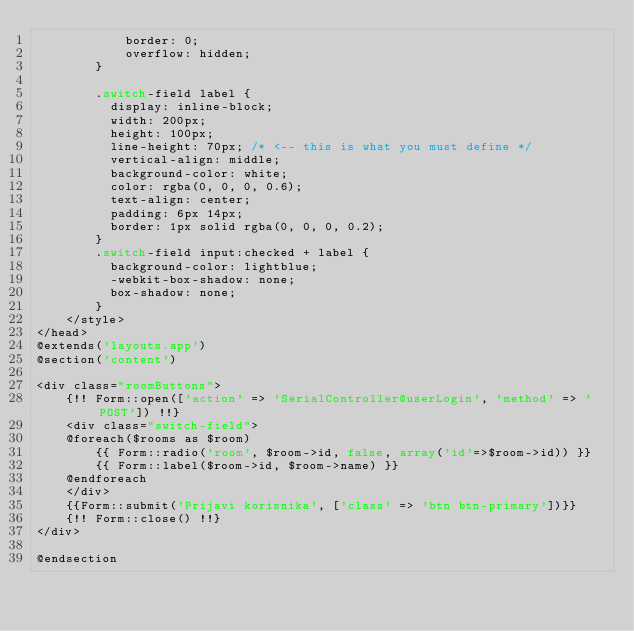Convert code to text. <code><loc_0><loc_0><loc_500><loc_500><_PHP_>            border: 0;
            overflow: hidden;
        }

        .switch-field label {
          display: inline-block;
          width: 200px;
          height: 100px;
          line-height: 70px; /* <-- this is what you must define */
          vertical-align: middle;
          background-color: white;
          color: rgba(0, 0, 0, 0.6);
          text-align: center;
          padding: 6px 14px;
          border: 1px solid rgba(0, 0, 0, 0.2);
        }
        .switch-field input:checked + label {
          background-color: lightblue;
          -webkit-box-shadow: none;
          box-shadow: none;
        }
    </style>
</head>
@extends('layouts.app')
@section('content')

<div class="roomButtons">
    {!! Form::open(['action' => 'SerialController@userLogin', 'method' => 'POST']) !!}
    <div class="switch-field">
    @foreach($rooms as $room)
        {{ Form::radio('room', $room->id, false, array('id'=>$room->id)) }}
        {{ Form::label($room->id, $room->name) }}
    @endforeach
    </div>
    {{Form::submit('Prijavi korisnika', ['class' => 'btn btn-primary'])}}
    {!! Form::close() !!}
</div>

@endsection</code> 